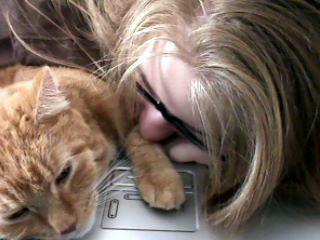How many cats are there?
Give a very brief answer. 1. 